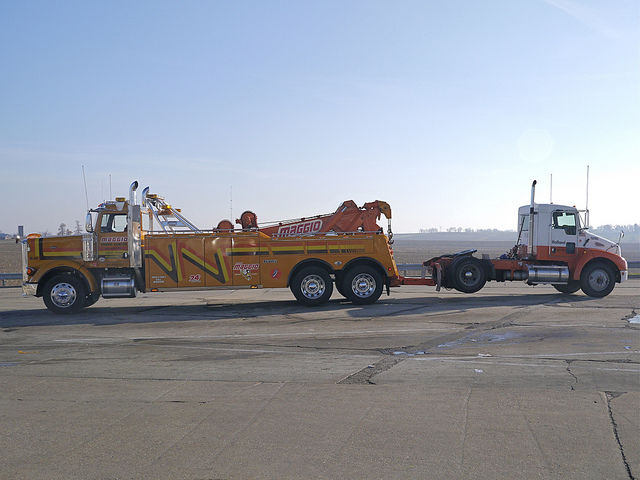Identify and read out the text in this image. MAGGIO 74 macold 